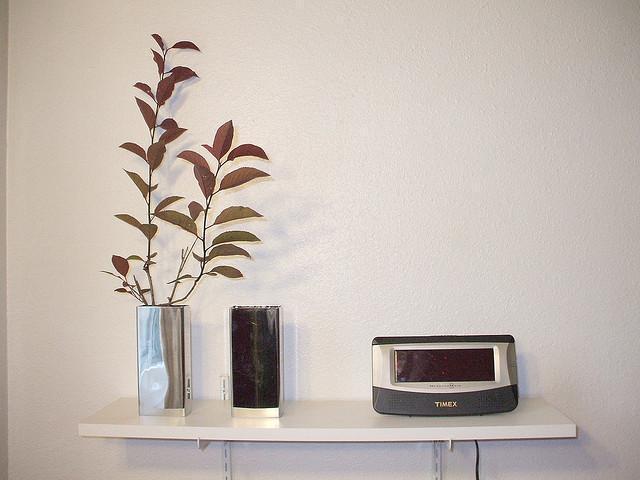How many different flowers are there?
Give a very brief answer. 1. How many vases are up against the wall?
Give a very brief answer. 2. How many hearts are there?
Give a very brief answer. 0. How many vases are in the photo?
Give a very brief answer. 2. How many people are standing with their hands on their knees?
Give a very brief answer. 0. 